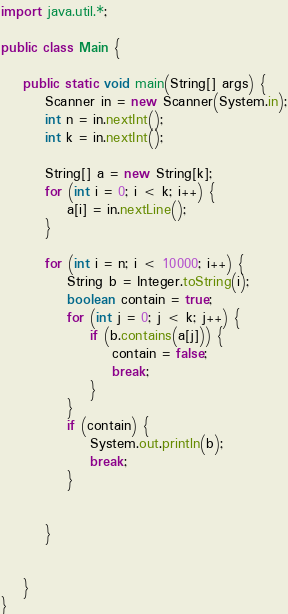<code> <loc_0><loc_0><loc_500><loc_500><_Java_>
import java.util.*;

public class Main {

    public static void main(String[] args) {
        Scanner in = new Scanner(System.in);
        int n = in.nextInt();
        int k = in.nextInt();

        String[] a = new String[k];
        for (int i = 0; i < k; i++) {
            a[i] = in.nextLine();
        }

        for (int i = n; i < 10000; i++) {
            String b = Integer.toString(i);
            boolean contain = true;
            for (int j = 0; j < k; j++) {
                if (b.contains(a[j])) {
                    contain = false;
                    break;
                }
            }
            if (contain) {
                System.out.println(b);
                break;
            }


        }


    }
}</code> 